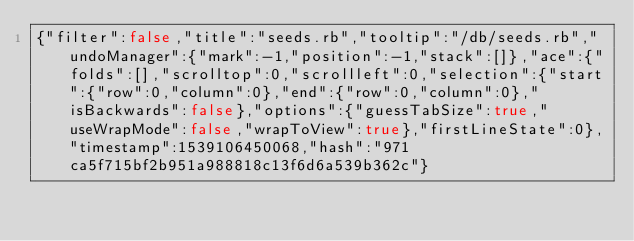<code> <loc_0><loc_0><loc_500><loc_500><_Ruby_>{"filter":false,"title":"seeds.rb","tooltip":"/db/seeds.rb","undoManager":{"mark":-1,"position":-1,"stack":[]},"ace":{"folds":[],"scrolltop":0,"scrollleft":0,"selection":{"start":{"row":0,"column":0},"end":{"row":0,"column":0},"isBackwards":false},"options":{"guessTabSize":true,"useWrapMode":false,"wrapToView":true},"firstLineState":0},"timestamp":1539106450068,"hash":"971ca5f715bf2b951a988818c13f6d6a539b362c"}</code> 